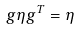Convert formula to latex. <formula><loc_0><loc_0><loc_500><loc_500>g \eta g ^ { T } = \eta</formula> 